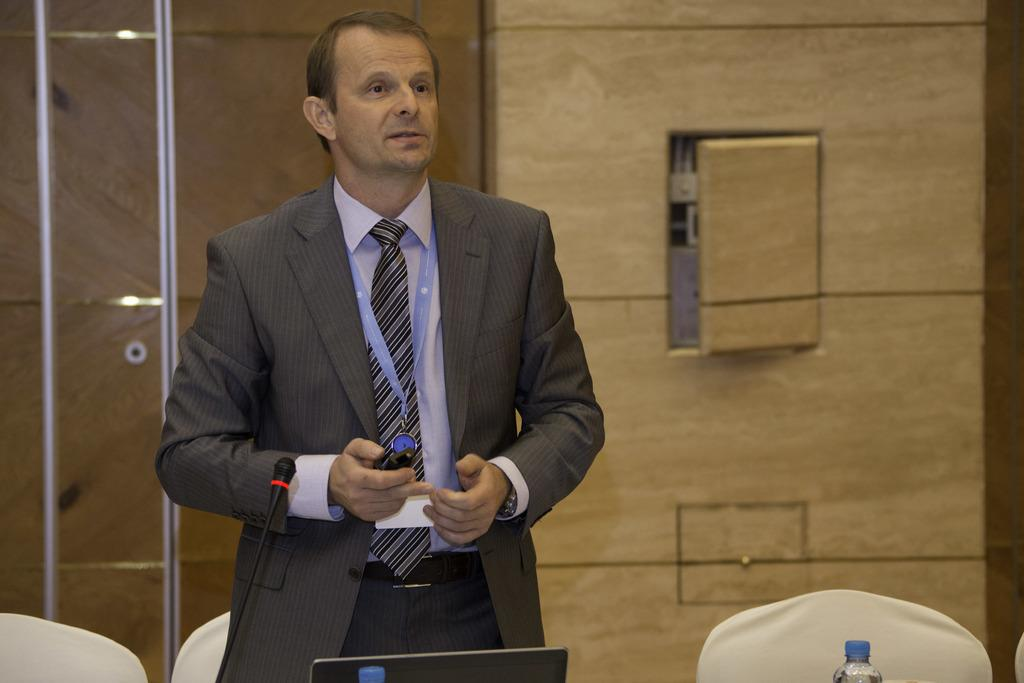What is the man in the image doing? The man is standing in the image and holding a remote in his hand. What objects are on the table in the image? A computer and a microphone are placed on the table in the image. What is the man possibly controlling with the remote? It is not clear from the image what the man is controlling with the remote, but it could be related to the computer or microphone on the table. What is visible in the background of the image? There is a wall in the background of the image. What type of street can be seen behind the man in the image? There is no street visible in the image; it only shows a wall in the background. Is there a volcano erupting in the image? No, there is no volcano present in the image. 